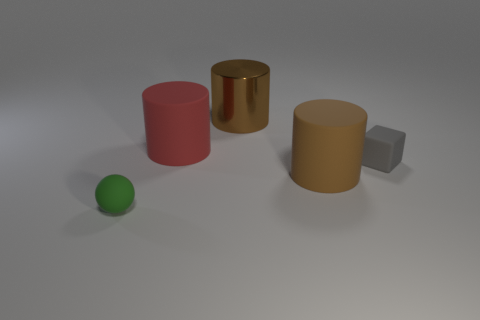Subtract all green cylinders. Subtract all green spheres. How many cylinders are left? 3 Add 2 big yellow rubber balls. How many objects exist? 7 Subtract all cylinders. How many objects are left? 2 Add 5 big matte cubes. How many big matte cubes exist? 5 Subtract 0 yellow cylinders. How many objects are left? 5 Subtract all small balls. Subtract all big brown things. How many objects are left? 2 Add 1 green rubber things. How many green rubber things are left? 2 